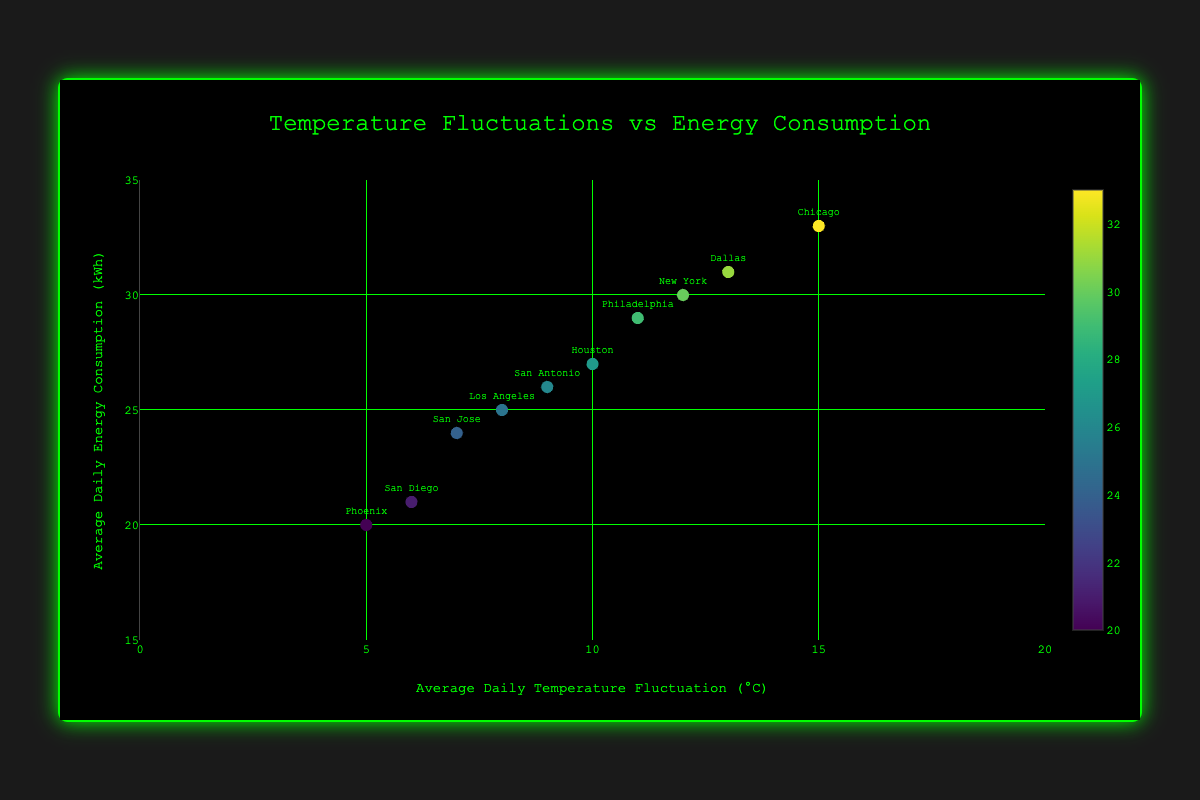What is the title of the scatter plot? The title of the scatter plot is displayed prominently at the top of the chart. The title describes the nature of the data being visualized.
Answer: Temperature Fluctuations vs Energy Consumption How many data points are plotted on the scatter plot? Count the number of markers on the scatter plot, each representing a data point.
Answer: 10 Which location has the highest average daily energy consumption? Identify the data point that corresponds to the highest value on the y-axis, then refer to the associated label.
Answer: Chicago What is the range of the x-axis in the scatter plot? Look at the minimum and maximum values labeled on the x-axis to determine the range.
Answer: 0 to 20 Which location has the lowest average daily temperature fluctuation? Find the data point with the smallest value on the x-axis and check the corresponding label to identify the location.
Answer: Phoenix How does energy consumption in San Diego compare to San Antonio? Locate the data points for San Diego and San Antonio on the scatter plot and compare their y-values to see which one is higher or if they are equal.
Answer: San Antonio has higher energy consumption than San Diego What is the average energy consumption for locations with temperature fluctuations above 10°C? Identify all data points with x-values greater than 10, sum their y-values, and divide by the number of these data points to find the average.
Answer: (30 + 33 + 29 + 31) / 4 = 30.75 Are there more locations with temperature fluctuations above or below 10°C? Count the data points that have x-values above 10 and below 10, respectively, and compare the counts.
Answer: Below 10°C Which location has the most moderate temperature fluctuation and what is its energy consumption? Find the data point closest to the mid-point of the x-axis range (10°C) and check the corresponding energy consumption.
Answer: Houston with 27 kWh Is there a visible trend or correlation between temperature fluctuations and energy consumption? Observe the overall distribution of the data points in relation to the x-axis and y-axis to determine if there is an upward or downward trend, or lack thereof.
Answer: Yes, a slight upward trend 